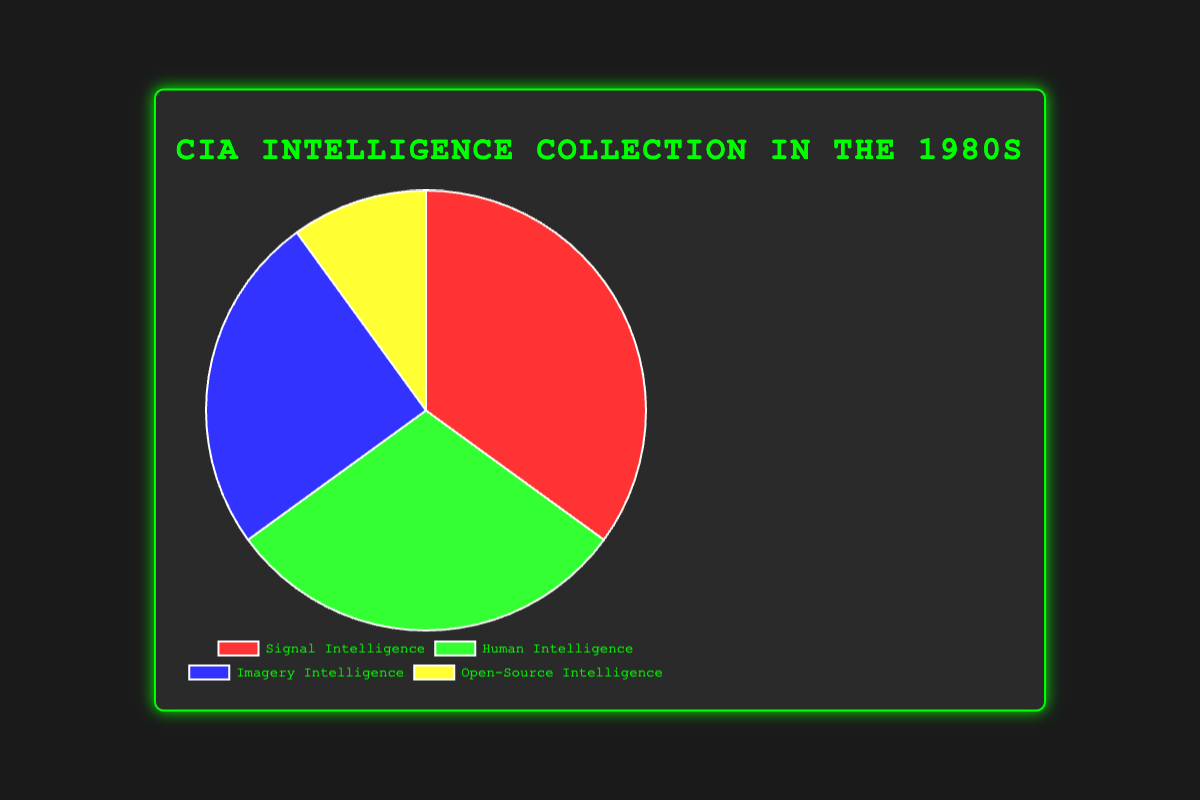What percentage of intelligence collection was signal intelligence in the 1980s? Signal intelligence accounts for 35% of the total intelligence collection. This can be directly seen in the figure's legend and segment size.
Answer: 35% Which type of intelligence had the smallest share of collection? Open-source intelligence had the smallest share at 10%. This can be determined by comparing the sizes of the pie segments visually.
Answer: Open-source intelligence What is the combined percentage of human and imagery intelligence? Adding the percentages of human intelligence (30%) and imagery intelligence (25%) gives: 30% + 25% = 55%
Answer: 55% Which type of intelligence had a larger share: human intelligence or signal intelligence? Signal intelligence had a larger share (35%) compared to human intelligence (30%). This is clear by comparing the segment sizes in the pie chart.
Answer: Signal intelligence What is the collective percentage of human, imagery, and open-source intelligence? Adding the percentages of human intelligence (30%), imagery intelligence (25%), and open-source intelligence (10%) gives: 30% + 25% + 10% = 65%
Answer: 65% What is the difference in percentage between human intelligence and imagery intelligence? Subtracting the percentage of imagery intelligence (25%) from human intelligence (30%) gives: 30% - 25% = 5%
Answer: 5% Identify the intelligence type represented by each of these colors: red, green, blue, and yellow. Red represents signal intelligence, green represents human intelligence, blue represents imagery intelligence, and yellow represents open-source intelligence. These color assignments can be observed from the legend in the figure.
Answer: Red: Signal, Green: Human, Blue: Imagery, Yellow: Open-source Which two types of intelligence collection add up to exactly 60%? Signal intelligence (35%) and imagery intelligence (25%) add up to 60%: 35% + 25% = 60%. This calculation involves adding the respective percentages.
Answer: Signal and Imagery If the total percentage for all types of intelligence collection is 100%, what percentage of the total is not signal intelligence? Subtracting the percentage of signal intelligence (35%) from the total (100%) gives: 100% - 35% = 65%
Answer: 65% 